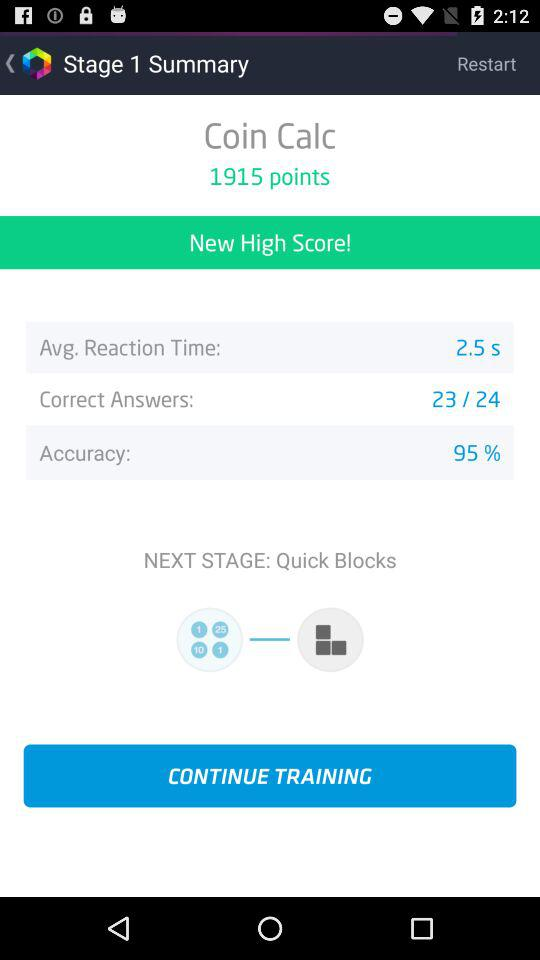How many answers are correct? There are 23 correct answers. 